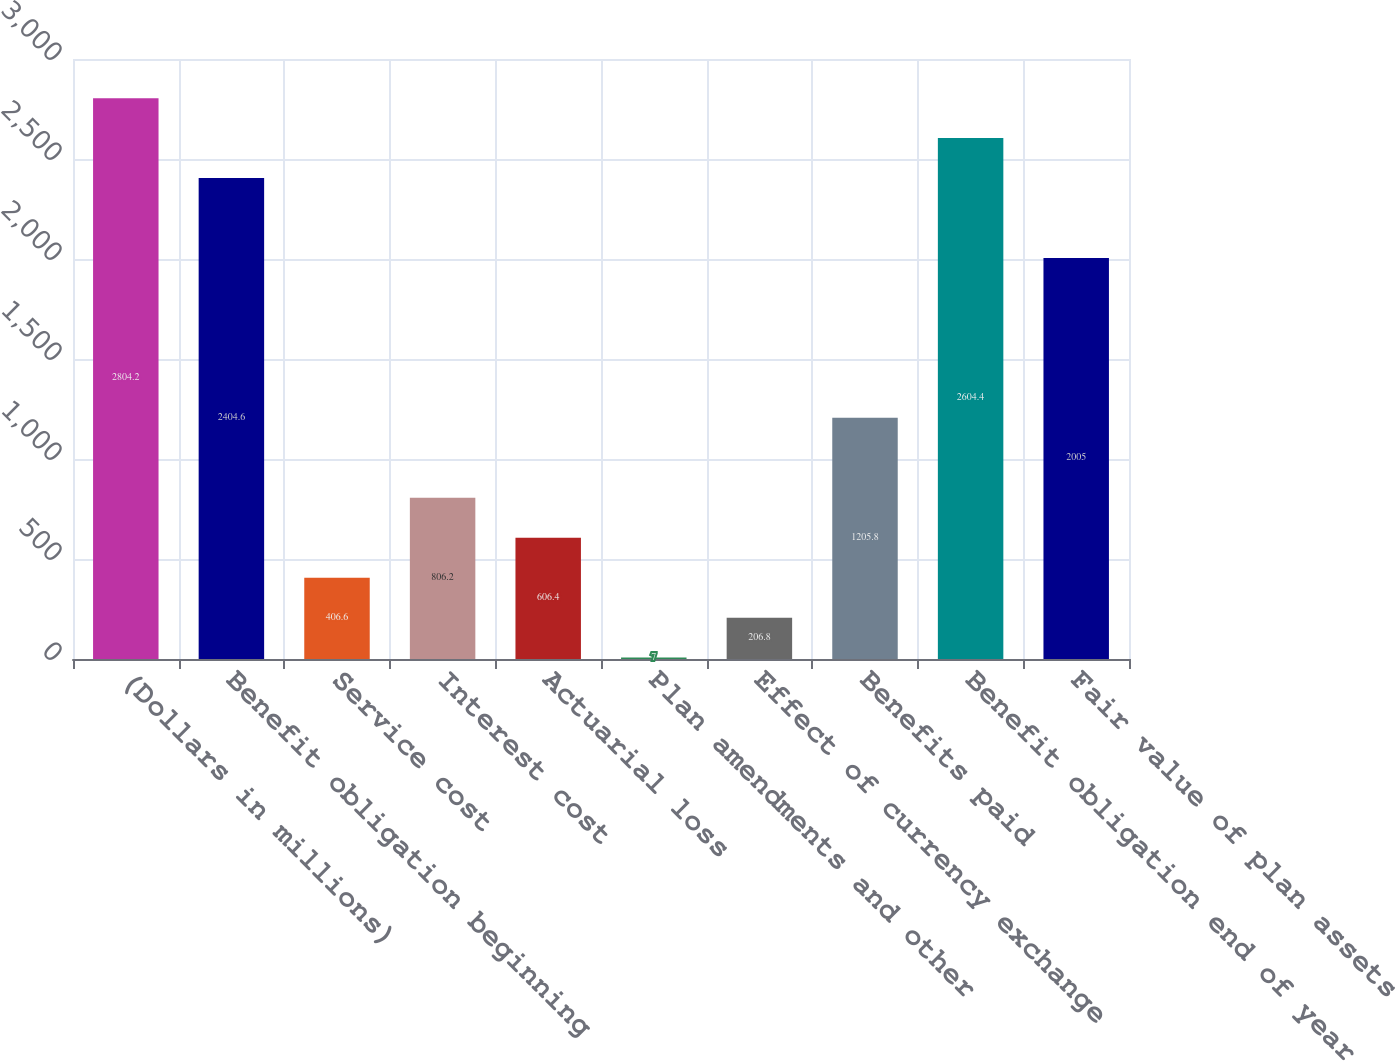<chart> <loc_0><loc_0><loc_500><loc_500><bar_chart><fcel>(Dollars in millions)<fcel>Benefit obligation beginning<fcel>Service cost<fcel>Interest cost<fcel>Actuarial loss<fcel>Plan amendments and other<fcel>Effect of currency exchange<fcel>Benefits paid<fcel>Benefit obligation end of year<fcel>Fair value of plan assets<nl><fcel>2804.2<fcel>2404.6<fcel>406.6<fcel>806.2<fcel>606.4<fcel>7<fcel>206.8<fcel>1205.8<fcel>2604.4<fcel>2005<nl></chart> 